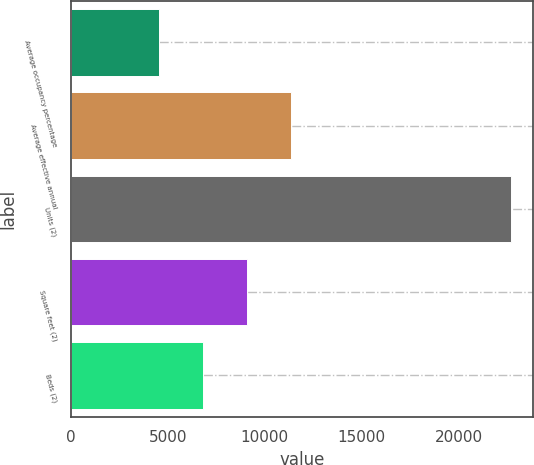<chart> <loc_0><loc_0><loc_500><loc_500><bar_chart><fcel>Average occupancy percentage<fcel>Average effective annual<fcel>Units (2)<fcel>Square feet (2)<fcel>Beds (2)<nl><fcel>4566.6<fcel>11359.5<fcel>22681<fcel>9095.2<fcel>6830.9<nl></chart> 